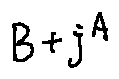Convert formula to latex. <formula><loc_0><loc_0><loc_500><loc_500>B + j ^ { A }</formula> 